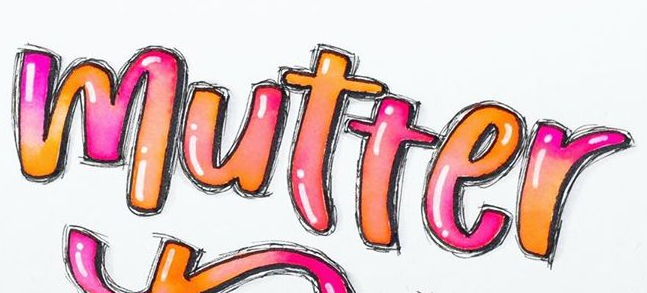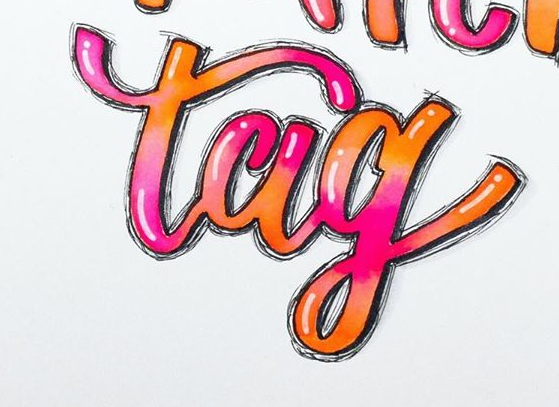Read the text content from these images in order, separated by a semicolon. mutter; tag 